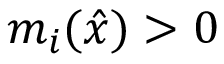Convert formula to latex. <formula><loc_0><loc_0><loc_500><loc_500>m _ { i } ( { \hat { x } } ) > 0</formula> 